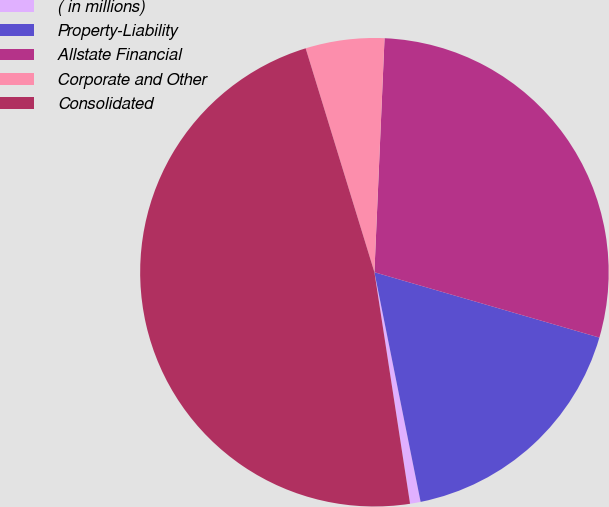<chart> <loc_0><loc_0><loc_500><loc_500><pie_chart><fcel>( in millions)<fcel>Property-Liability<fcel>Allstate Financial<fcel>Corporate and Other<fcel>Consolidated<nl><fcel>0.73%<fcel>17.34%<fcel>28.81%<fcel>5.43%<fcel>47.69%<nl></chart> 